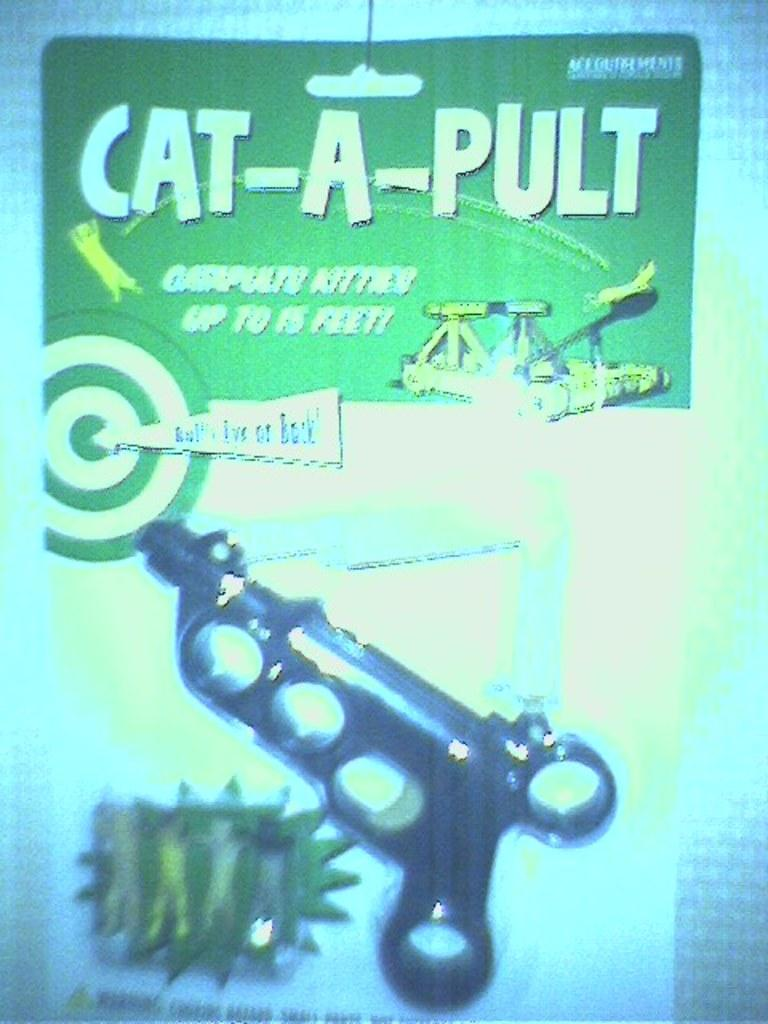Provide a one-sentence caption for the provided image. A Cat-A-Pult toy is displayed in green package with a red and white target on it. 